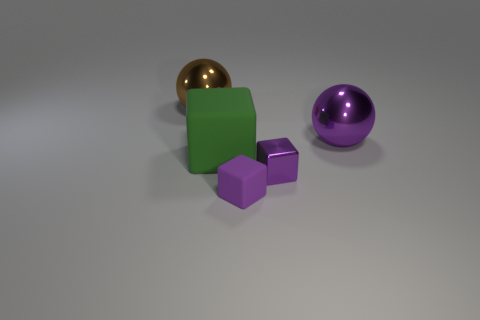How do the textures of the objects compare? The objects display a variety of textures: the green cube has a matte finish, the golden sphere boasts a polished surface, and the purple cube and sphere have a slightly reflective sheen that is less intense than the gold sphere's luster. Which object appears to be the brightest? The golden sphere appears to be the brightest due to its highly reflective surface that catches the light most effectively. 